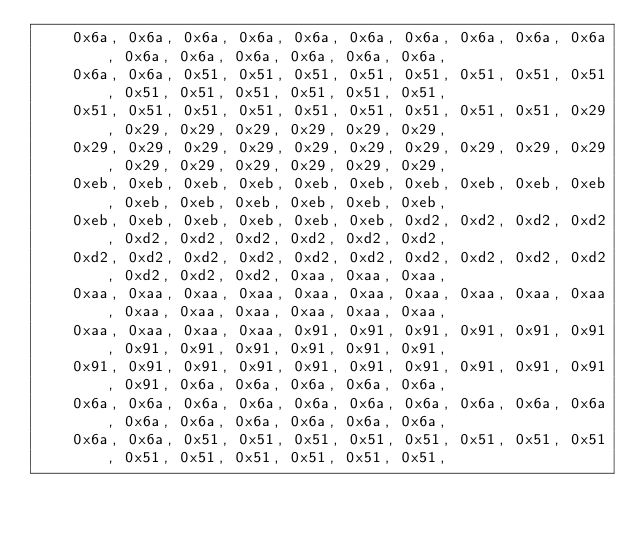Convert code to text. <code><loc_0><loc_0><loc_500><loc_500><_C_>	0x6a, 0x6a, 0x6a, 0x6a, 0x6a, 0x6a, 0x6a, 0x6a, 0x6a, 0x6a, 0x6a, 0x6a, 0x6a, 0x6a, 0x6a, 0x6a,
	0x6a, 0x6a, 0x51, 0x51, 0x51, 0x51, 0x51, 0x51, 0x51, 0x51, 0x51, 0x51, 0x51, 0x51, 0x51, 0x51,
	0x51, 0x51, 0x51, 0x51, 0x51, 0x51, 0x51, 0x51, 0x51, 0x29, 0x29, 0x29, 0x29, 0x29, 0x29, 0x29,
	0x29, 0x29, 0x29, 0x29, 0x29, 0x29, 0x29, 0x29, 0x29, 0x29, 0x29, 0x29, 0x29, 0x29, 0x29, 0x29,
	0xeb, 0xeb, 0xeb, 0xeb, 0xeb, 0xeb, 0xeb, 0xeb, 0xeb, 0xeb, 0xeb, 0xeb, 0xeb, 0xeb, 0xeb, 0xeb,
	0xeb, 0xeb, 0xeb, 0xeb, 0xeb, 0xeb, 0xd2, 0xd2, 0xd2, 0xd2, 0xd2, 0xd2, 0xd2, 0xd2, 0xd2, 0xd2,
	0xd2, 0xd2, 0xd2, 0xd2, 0xd2, 0xd2, 0xd2, 0xd2, 0xd2, 0xd2, 0xd2, 0xd2, 0xd2, 0xaa, 0xaa, 0xaa,
	0xaa, 0xaa, 0xaa, 0xaa, 0xaa, 0xaa, 0xaa, 0xaa, 0xaa, 0xaa, 0xaa, 0xaa, 0xaa, 0xaa, 0xaa, 0xaa,
	0xaa, 0xaa, 0xaa, 0xaa, 0x91, 0x91, 0x91, 0x91, 0x91, 0x91, 0x91, 0x91, 0x91, 0x91, 0x91, 0x91,
	0x91, 0x91, 0x91, 0x91, 0x91, 0x91, 0x91, 0x91, 0x91, 0x91, 0x91, 0x6a, 0x6a, 0x6a, 0x6a, 0x6a,
	0x6a, 0x6a, 0x6a, 0x6a, 0x6a, 0x6a, 0x6a, 0x6a, 0x6a, 0x6a, 0x6a, 0x6a, 0x6a, 0x6a, 0x6a, 0x6a,
	0x6a, 0x6a, 0x51, 0x51, 0x51, 0x51, 0x51, 0x51, 0x51, 0x51, 0x51, 0x51, 0x51, 0x51, 0x51, 0x51,</code> 